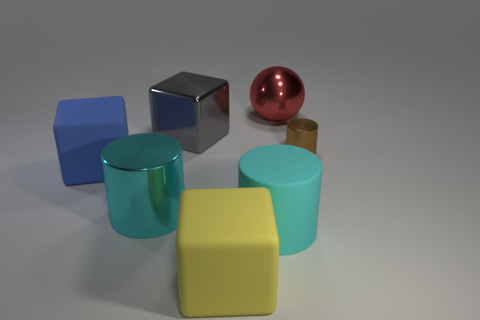How many objects are either small gray rubber objects or cubes that are behind the yellow matte object?
Give a very brief answer. 2. What is the size of the cube in front of the big blue matte cube?
Your answer should be compact. Large. Are there fewer big cyan matte cylinders that are in front of the large cyan matte cylinder than matte things that are behind the yellow object?
Make the answer very short. Yes. There is a thing that is both behind the brown thing and in front of the red sphere; what material is it?
Ensure brevity in your answer.  Metal. What is the shape of the big metal object to the right of the rubber block that is right of the big gray metal block?
Give a very brief answer. Sphere. Does the small cylinder have the same color as the metallic sphere?
Offer a very short reply. No. How many gray things are large cubes or tiny metallic cubes?
Give a very brief answer. 1. There is a matte cylinder; are there any big metal cubes to the right of it?
Offer a very short reply. No. What is the size of the brown cylinder?
Provide a succinct answer. Small. There is a gray object that is the same shape as the blue rubber object; what size is it?
Offer a very short reply. Large. 